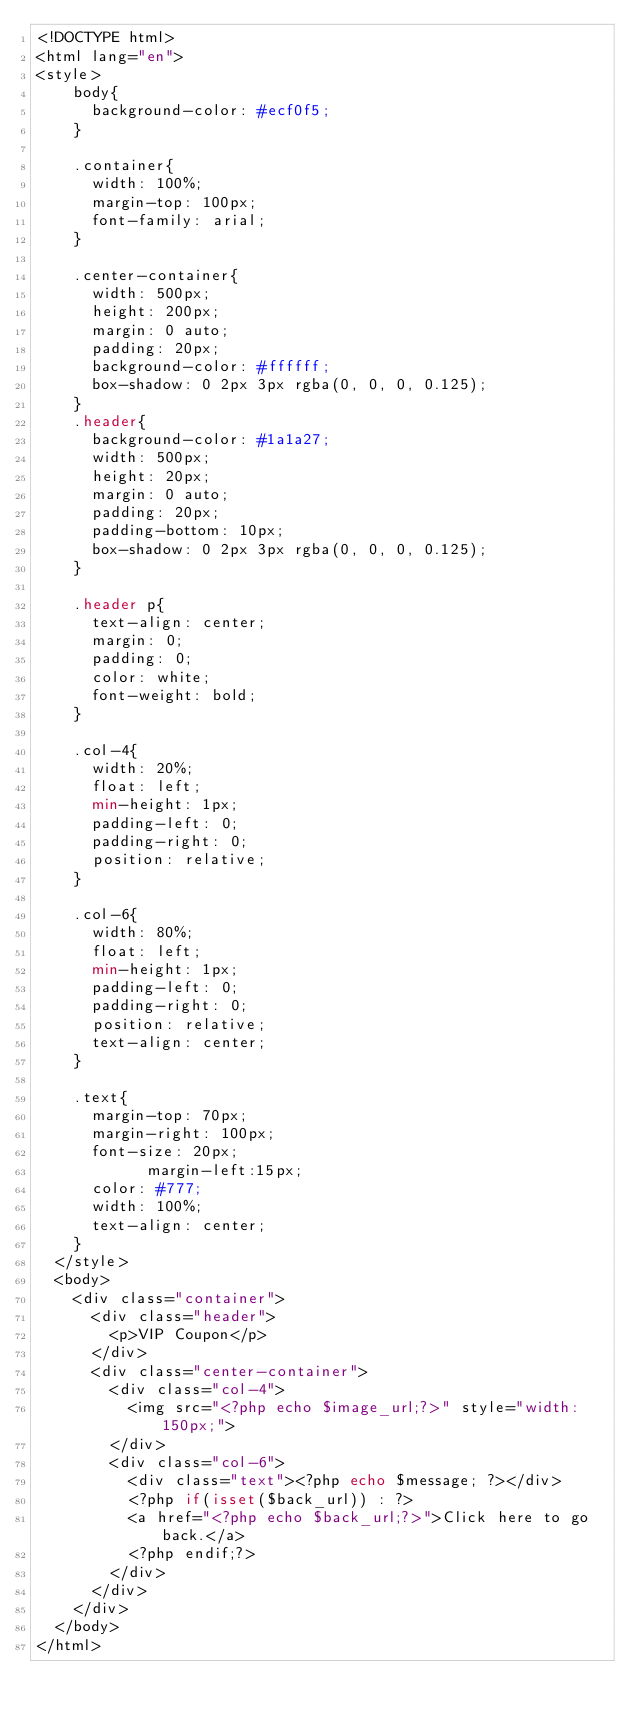Convert code to text. <code><loc_0><loc_0><loc_500><loc_500><_PHP_><!DOCTYPE html>
<html lang="en">
<style>
		body{
			background-color: #ecf0f5;
		}

		.container{
			width: 100%;
			margin-top: 100px;
			font-family: arial;
		}
		
		.center-container{
			width: 500px;
			height: 200px;
			margin: 0 auto;
			padding: 20px;
			background-color: #ffffff;
			box-shadow: 0 2px 3px rgba(0, 0, 0, 0.125);
		}
		.header{
			background-color: #1a1a27;
			width: 500px;
			height: 20px;
			margin: 0 auto;
			padding: 20px;
			padding-bottom: 10px;
			box-shadow: 0 2px 3px rgba(0, 0, 0, 0.125);
		}
		
		.header p{
			text-align: center;
			margin: 0;
			padding: 0;
			color: white;
			font-weight: bold;
		}
		
		.col-4{
			width: 20%;
			float: left;
			min-height: 1px;
			padding-left: 0;
			padding-right: 0;
			position: relative;
		}
		
		.col-6{
			width: 80%;
			float: left;
			min-height: 1px;
			padding-left: 0;
			padding-right: 0;
			position: relative;
			text-align: center;
		}
	
		.text{
			margin-top: 70px;
			margin-right: 100px;
			font-size: 20px;
            margin-left:15px;
			color: #777;
			width: 100%;
			text-align: center;
		}
	</style>
	<body>
		<div class="container">
			<div class="header">
				<p>VIP Coupon</p>
			</div>
			<div class="center-container">
				<div class="col-4">
					<img src="<?php echo $image_url;?>" style="width: 150px;">
				</div>
				<div class="col-6">
					<div class="text"><?php echo $message; ?></div>
					<?php if(isset($back_url)) : ?>
					<a href="<?php echo $back_url;?>">Click here to go back.</a>
					<?php endif;?>
				</div>
			</div>
		</div>
	</body>
</html>

</code> 